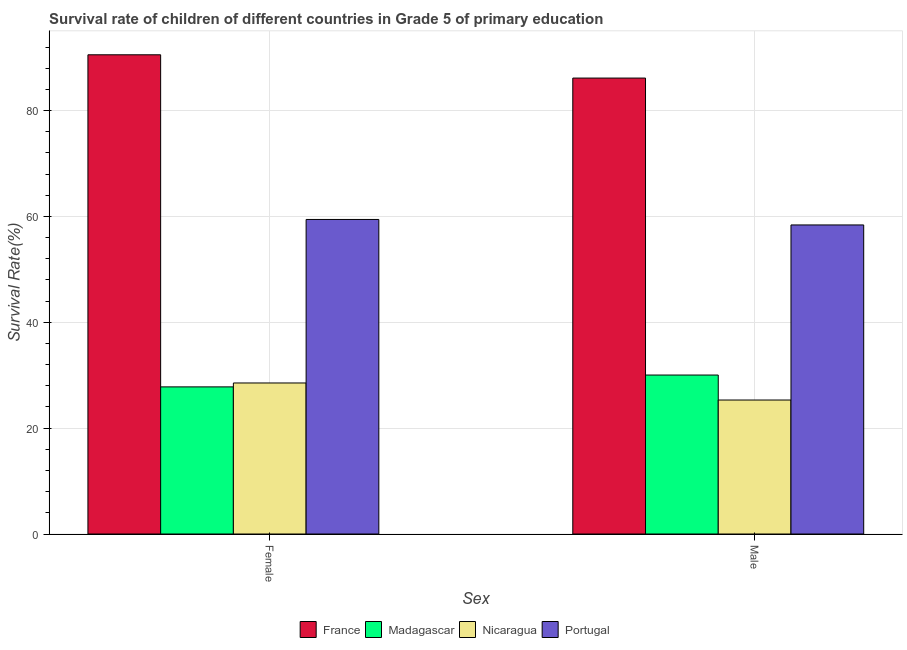Are the number of bars per tick equal to the number of legend labels?
Make the answer very short. Yes. How many bars are there on the 2nd tick from the left?
Make the answer very short. 4. What is the label of the 1st group of bars from the left?
Provide a succinct answer. Female. What is the survival rate of female students in primary education in Portugal?
Your response must be concise. 59.44. Across all countries, what is the maximum survival rate of female students in primary education?
Your answer should be very brief. 90.56. Across all countries, what is the minimum survival rate of female students in primary education?
Your response must be concise. 27.8. In which country was the survival rate of female students in primary education minimum?
Offer a terse response. Madagascar. What is the total survival rate of male students in primary education in the graph?
Offer a very short reply. 199.91. What is the difference between the survival rate of female students in primary education in France and that in Madagascar?
Your response must be concise. 62.76. What is the difference between the survival rate of female students in primary education in Nicaragua and the survival rate of male students in primary education in France?
Offer a very short reply. -57.62. What is the average survival rate of female students in primary education per country?
Your answer should be compact. 51.58. What is the difference between the survival rate of female students in primary education and survival rate of male students in primary education in Portugal?
Make the answer very short. 1.04. What is the ratio of the survival rate of male students in primary education in France to that in Nicaragua?
Keep it short and to the point. 3.4. In how many countries, is the survival rate of female students in primary education greater than the average survival rate of female students in primary education taken over all countries?
Keep it short and to the point. 2. How many bars are there?
Keep it short and to the point. 8. How many countries are there in the graph?
Your answer should be very brief. 4. What is the difference between two consecutive major ticks on the Y-axis?
Give a very brief answer. 20. Are the values on the major ticks of Y-axis written in scientific E-notation?
Ensure brevity in your answer.  No. Does the graph contain any zero values?
Your answer should be very brief. No. What is the title of the graph?
Give a very brief answer. Survival rate of children of different countries in Grade 5 of primary education. What is the label or title of the X-axis?
Provide a short and direct response. Sex. What is the label or title of the Y-axis?
Make the answer very short. Survival Rate(%). What is the Survival Rate(%) of France in Female?
Give a very brief answer. 90.56. What is the Survival Rate(%) in Madagascar in Female?
Your answer should be very brief. 27.8. What is the Survival Rate(%) in Nicaragua in Female?
Your answer should be very brief. 28.54. What is the Survival Rate(%) in Portugal in Female?
Your answer should be compact. 59.44. What is the Survival Rate(%) of France in Male?
Provide a succinct answer. 86.16. What is the Survival Rate(%) in Madagascar in Male?
Offer a terse response. 30.04. What is the Survival Rate(%) of Nicaragua in Male?
Your answer should be compact. 25.32. What is the Survival Rate(%) in Portugal in Male?
Provide a succinct answer. 58.4. Across all Sex, what is the maximum Survival Rate(%) of France?
Ensure brevity in your answer.  90.56. Across all Sex, what is the maximum Survival Rate(%) of Madagascar?
Give a very brief answer. 30.04. Across all Sex, what is the maximum Survival Rate(%) in Nicaragua?
Make the answer very short. 28.54. Across all Sex, what is the maximum Survival Rate(%) of Portugal?
Your answer should be compact. 59.44. Across all Sex, what is the minimum Survival Rate(%) in France?
Offer a terse response. 86.16. Across all Sex, what is the minimum Survival Rate(%) in Madagascar?
Offer a very short reply. 27.8. Across all Sex, what is the minimum Survival Rate(%) of Nicaragua?
Your response must be concise. 25.32. Across all Sex, what is the minimum Survival Rate(%) in Portugal?
Offer a terse response. 58.4. What is the total Survival Rate(%) of France in the graph?
Provide a succinct answer. 176.71. What is the total Survival Rate(%) of Madagascar in the graph?
Your answer should be very brief. 57.84. What is the total Survival Rate(%) of Nicaragua in the graph?
Provide a short and direct response. 53.86. What is the total Survival Rate(%) of Portugal in the graph?
Ensure brevity in your answer.  117.84. What is the difference between the Survival Rate(%) in France in Female and that in Male?
Your answer should be very brief. 4.4. What is the difference between the Survival Rate(%) in Madagascar in Female and that in Male?
Your answer should be very brief. -2.24. What is the difference between the Survival Rate(%) of Nicaragua in Female and that in Male?
Make the answer very short. 3.22. What is the difference between the Survival Rate(%) in Portugal in Female and that in Male?
Offer a very short reply. 1.04. What is the difference between the Survival Rate(%) in France in Female and the Survival Rate(%) in Madagascar in Male?
Keep it short and to the point. 60.52. What is the difference between the Survival Rate(%) in France in Female and the Survival Rate(%) in Nicaragua in Male?
Provide a short and direct response. 65.24. What is the difference between the Survival Rate(%) of France in Female and the Survival Rate(%) of Portugal in Male?
Offer a very short reply. 32.16. What is the difference between the Survival Rate(%) in Madagascar in Female and the Survival Rate(%) in Nicaragua in Male?
Your answer should be compact. 2.48. What is the difference between the Survival Rate(%) in Madagascar in Female and the Survival Rate(%) in Portugal in Male?
Provide a succinct answer. -30.6. What is the difference between the Survival Rate(%) of Nicaragua in Female and the Survival Rate(%) of Portugal in Male?
Your answer should be compact. -29.86. What is the average Survival Rate(%) in France per Sex?
Provide a succinct answer. 88.36. What is the average Survival Rate(%) in Madagascar per Sex?
Provide a succinct answer. 28.92. What is the average Survival Rate(%) of Nicaragua per Sex?
Your answer should be compact. 26.93. What is the average Survival Rate(%) of Portugal per Sex?
Your answer should be compact. 58.92. What is the difference between the Survival Rate(%) of France and Survival Rate(%) of Madagascar in Female?
Keep it short and to the point. 62.76. What is the difference between the Survival Rate(%) in France and Survival Rate(%) in Nicaragua in Female?
Keep it short and to the point. 62.02. What is the difference between the Survival Rate(%) in France and Survival Rate(%) in Portugal in Female?
Ensure brevity in your answer.  31.12. What is the difference between the Survival Rate(%) of Madagascar and Survival Rate(%) of Nicaragua in Female?
Your response must be concise. -0.74. What is the difference between the Survival Rate(%) in Madagascar and Survival Rate(%) in Portugal in Female?
Offer a very short reply. -31.64. What is the difference between the Survival Rate(%) in Nicaragua and Survival Rate(%) in Portugal in Female?
Offer a very short reply. -30.9. What is the difference between the Survival Rate(%) of France and Survival Rate(%) of Madagascar in Male?
Your answer should be very brief. 56.12. What is the difference between the Survival Rate(%) in France and Survival Rate(%) in Nicaragua in Male?
Your response must be concise. 60.84. What is the difference between the Survival Rate(%) in France and Survival Rate(%) in Portugal in Male?
Ensure brevity in your answer.  27.75. What is the difference between the Survival Rate(%) of Madagascar and Survival Rate(%) of Nicaragua in Male?
Offer a very short reply. 4.72. What is the difference between the Survival Rate(%) in Madagascar and Survival Rate(%) in Portugal in Male?
Give a very brief answer. -28.36. What is the difference between the Survival Rate(%) of Nicaragua and Survival Rate(%) of Portugal in Male?
Make the answer very short. -33.08. What is the ratio of the Survival Rate(%) of France in Female to that in Male?
Your answer should be compact. 1.05. What is the ratio of the Survival Rate(%) of Madagascar in Female to that in Male?
Give a very brief answer. 0.93. What is the ratio of the Survival Rate(%) in Nicaragua in Female to that in Male?
Ensure brevity in your answer.  1.13. What is the ratio of the Survival Rate(%) in Portugal in Female to that in Male?
Offer a terse response. 1.02. What is the difference between the highest and the second highest Survival Rate(%) in France?
Offer a very short reply. 4.4. What is the difference between the highest and the second highest Survival Rate(%) of Madagascar?
Make the answer very short. 2.24. What is the difference between the highest and the second highest Survival Rate(%) in Nicaragua?
Give a very brief answer. 3.22. What is the difference between the highest and the second highest Survival Rate(%) in Portugal?
Your response must be concise. 1.04. What is the difference between the highest and the lowest Survival Rate(%) of France?
Keep it short and to the point. 4.4. What is the difference between the highest and the lowest Survival Rate(%) of Madagascar?
Provide a succinct answer. 2.24. What is the difference between the highest and the lowest Survival Rate(%) of Nicaragua?
Keep it short and to the point. 3.22. What is the difference between the highest and the lowest Survival Rate(%) in Portugal?
Provide a succinct answer. 1.04. 